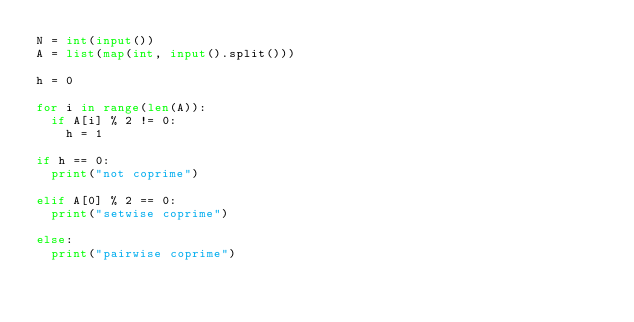<code> <loc_0><loc_0><loc_500><loc_500><_Python_>N = int(input())
A = list(map(int, input().split()))

h = 0

for i in range(len(A)):
  if A[i] % 2 != 0:
    h = 1

if h == 0:
  print("not coprime")
  
elif A[0] % 2 == 0:
  print("setwise coprime")
  
else:
  print("pairwise coprime")</code> 